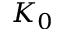<formula> <loc_0><loc_0><loc_500><loc_500>K _ { 0 }</formula> 